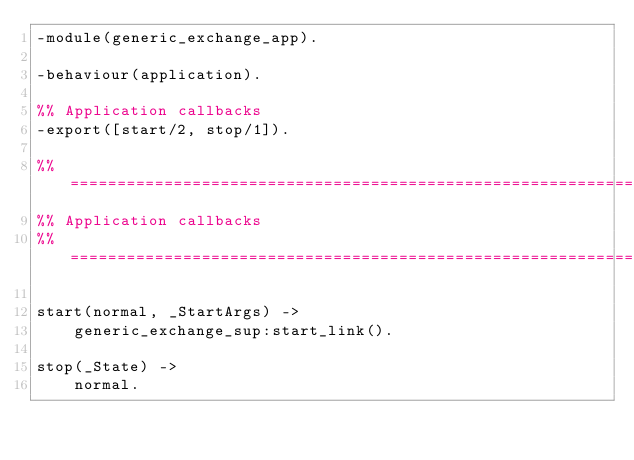Convert code to text. <code><loc_0><loc_0><loc_500><loc_500><_Erlang_>-module(generic_exchange_app).

-behaviour(application).

%% Application callbacks
-export([start/2, stop/1]).

%% ===================================================================
%% Application callbacks
%% ===================================================================

start(normal, _StartArgs) ->
    generic_exchange_sup:start_link().

stop(_State) ->
    normal.
</code> 